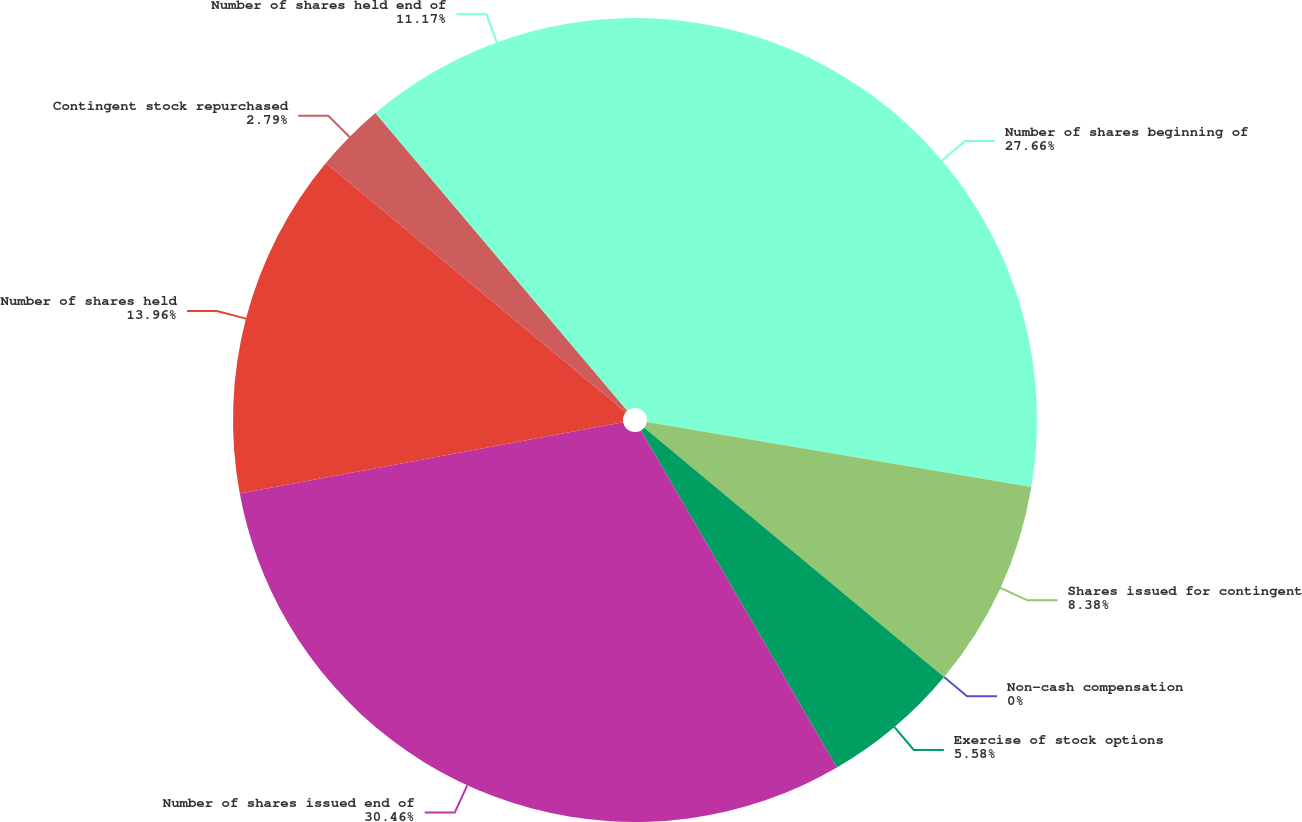Convert chart. <chart><loc_0><loc_0><loc_500><loc_500><pie_chart><fcel>Number of shares beginning of<fcel>Shares issued for contingent<fcel>Non-cash compensation<fcel>Exercise of stock options<fcel>Number of shares issued end of<fcel>Number of shares held<fcel>Contingent stock repurchased<fcel>Number of shares held end of<nl><fcel>27.66%<fcel>8.38%<fcel>0.0%<fcel>5.58%<fcel>30.45%<fcel>13.96%<fcel>2.79%<fcel>11.17%<nl></chart> 